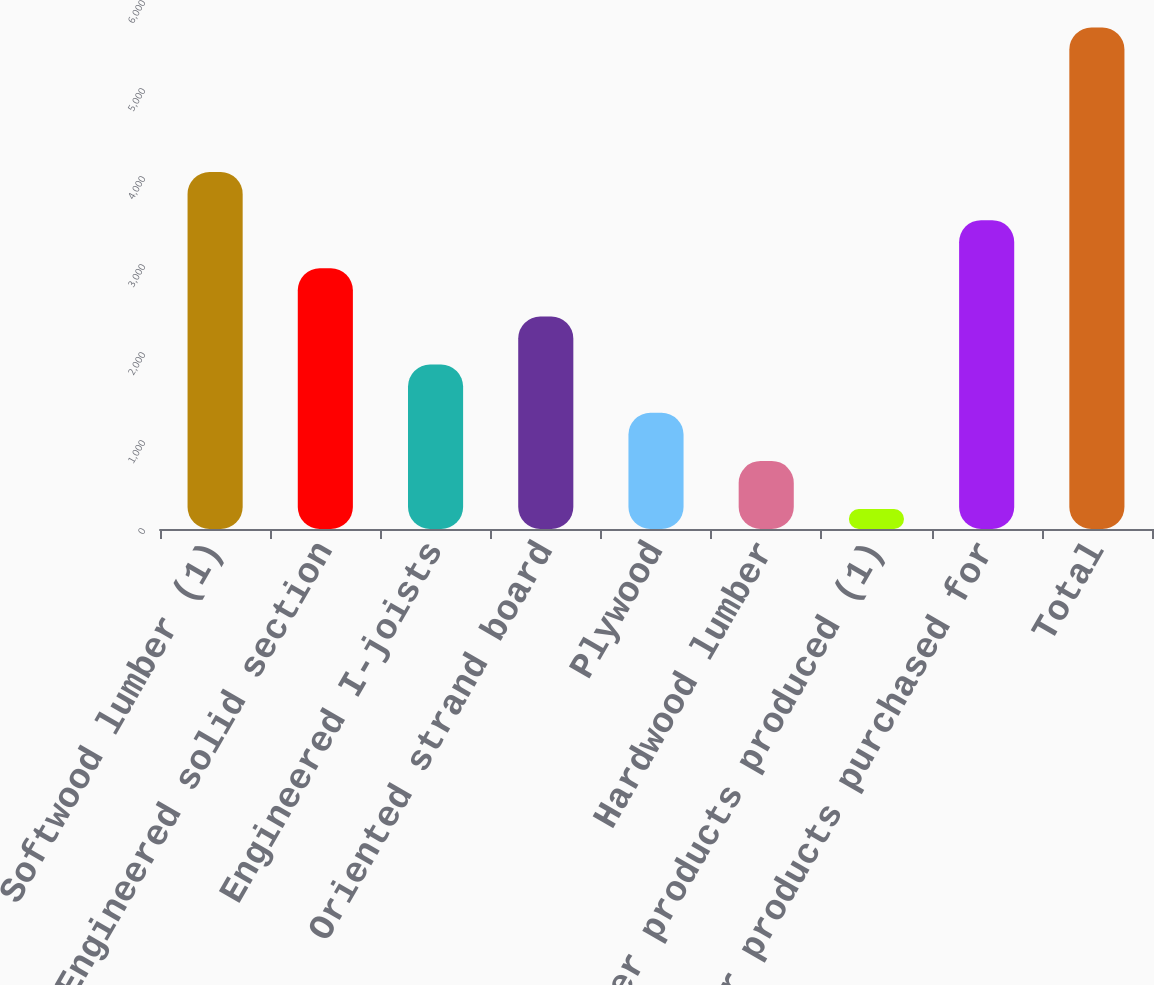<chart> <loc_0><loc_0><loc_500><loc_500><bar_chart><fcel>Softwood lumber (1)<fcel>Engineered solid section<fcel>Engineered I-joists<fcel>Oriented strand board<fcel>Plywood<fcel>Hardwood lumber<fcel>Other products produced (1)<fcel>Other products purchased for<fcel>Total<nl><fcel>4057.1<fcel>2962.5<fcel>1867.9<fcel>2415.2<fcel>1320.6<fcel>773.3<fcel>226<fcel>3509.8<fcel>5699<nl></chart> 